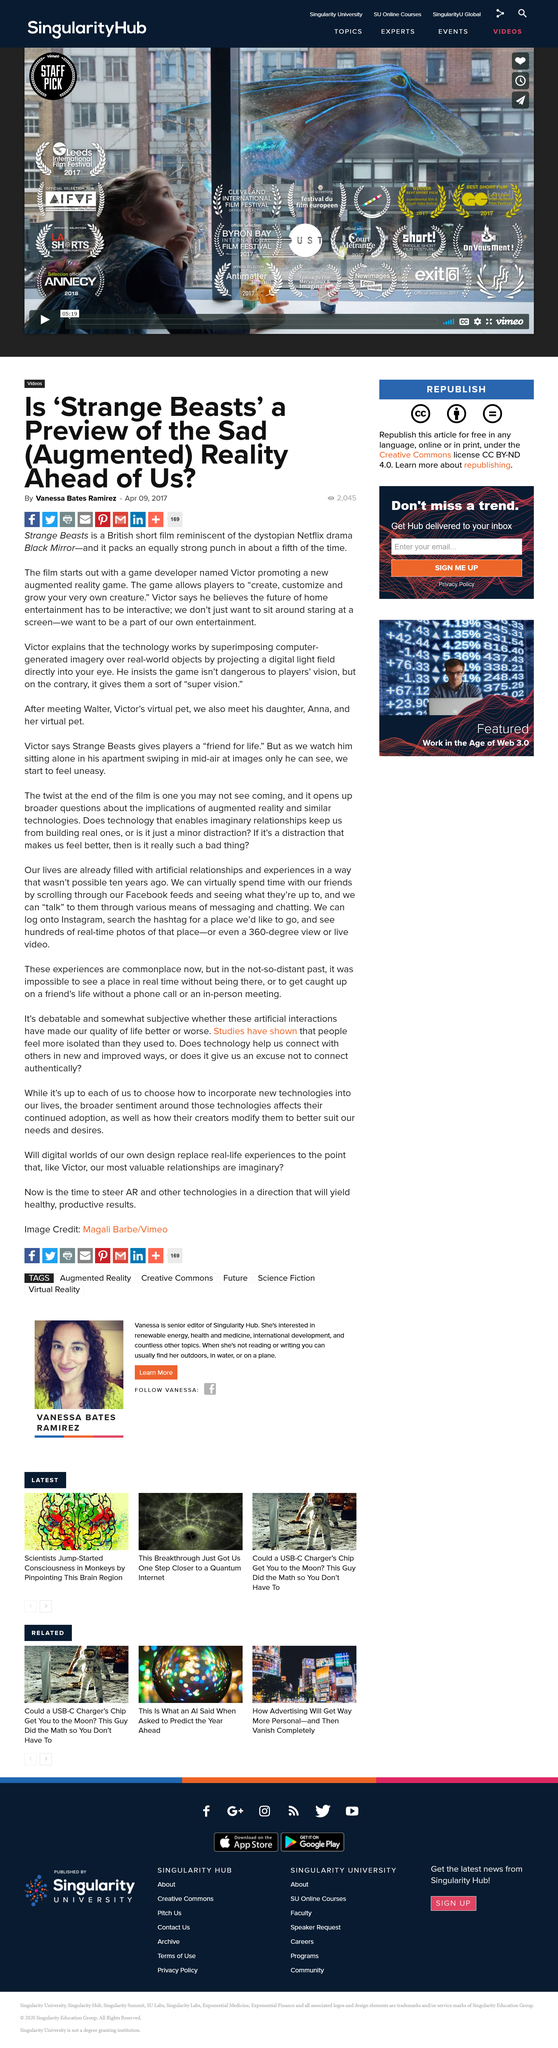Outline some significant characteristics in this image. Yes, Strange Beasts has a game developer named Victor, and he has developed at least one game for Strange Beasts. Strange Beasts is similar to the popular science fiction anthology series Black Mirror, which features standalone episodes with dark and thought-provoking themes. Yes, "Strange Beasts" is a British film, as it was not produced by an American company, nor was it set in the United States. 